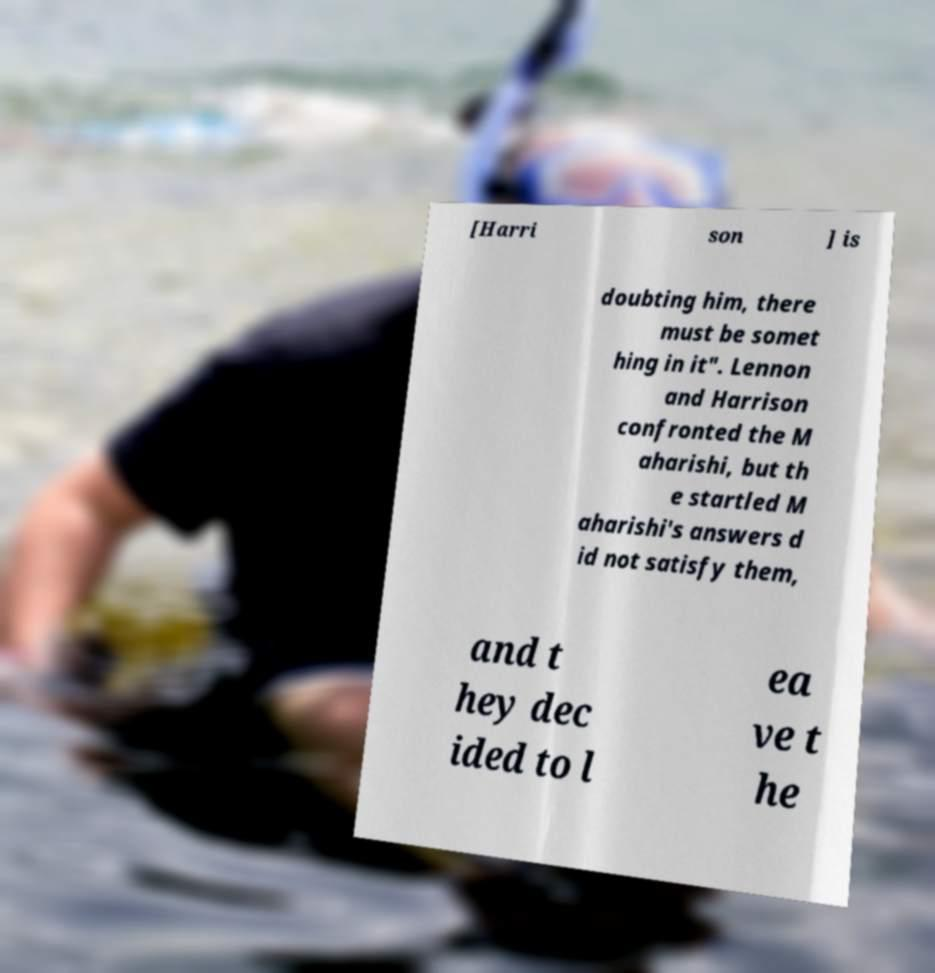I need the written content from this picture converted into text. Can you do that? [Harri son ] is doubting him, there must be somet hing in it". Lennon and Harrison confronted the M aharishi, but th e startled M aharishi's answers d id not satisfy them, and t hey dec ided to l ea ve t he 